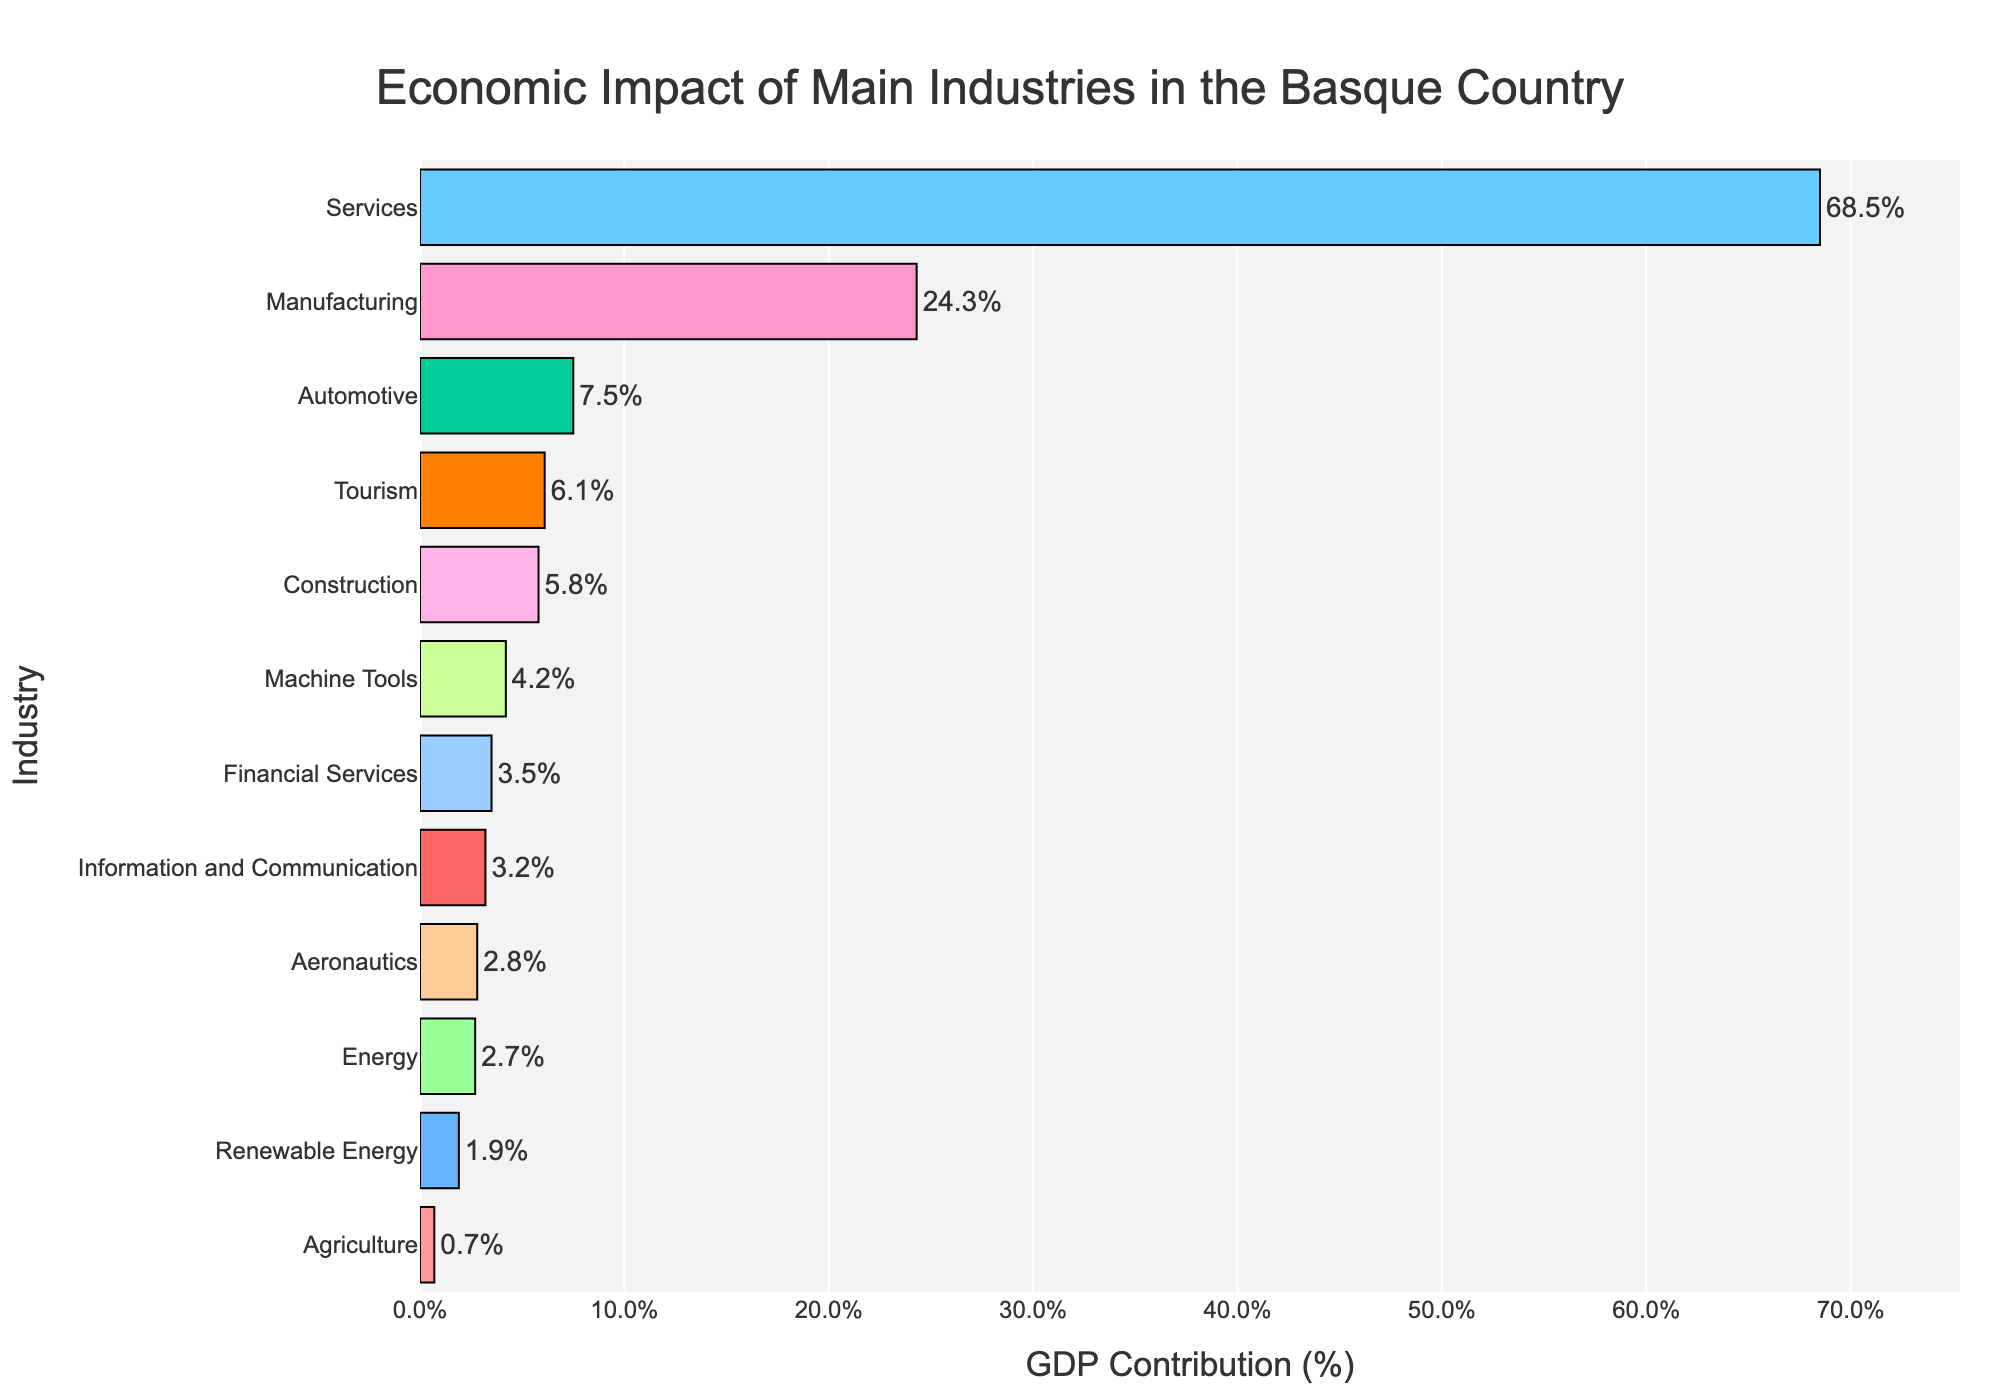Which industry has the highest GDP contribution? The bar representing the Services industry is the longest, indicating that it has the highest GDP contribution.
Answer: Services What is the total GDP contribution of Manufacturing, Automotive, and Machine Tools combined? Add the GDP contributions: Manufacturing (24.3) + Automotive (7.5) + Machine Tools (4.2). The sum is 24.3 + 7.5 + 4.2 = 36.0%.
Answer: 36.0% Which two industries contribute less than 1% to GDP? The bars for Agriculture and Renewable Energy are the shortest and positioned at around 0.7% and 1.9%, respectively. Only Agriculture is less than 1%.
Answer: Agriculture How much more does Services contribute to GDP compared to Manufacturing? Subtract the GDP contribution of Manufacturing from that of Services: 68.5 - 24.3 = 44.2%.
Answer: 44.2% What is the average GDP contribution of the bottom three industries? Sum the GDP contributions of the bottom three industries (Agriculture: 0.7%, Renewable Energy: 1.9%, and Energy: 2.7%) and divide by 3: (0.7 + 1.9 + 2.7) / 3 = 1.77%.
Answer: 1.77% Which industry has a higher GDP contribution: Financial Services or Information and Communication? Compare the bars representing Financial Services (3.5%) and Information and Communication (3.2%). Financial Services is higher.
Answer: Financial Services Is Tourism's GDP contribution higher than Construction? Compare the bars representing Tourism (6.1%) and Construction (5.8%). Tourism is slightly higher.
Answer: Yes What is the difference in GDP contribution between the Automotive and Aeronautics industries? Subtract the GDP contribution of Aeronautics from that of Automotive: 7.5 - 2.8 = 4.7%.
Answer: 4.7% Which industry has a GDP contribution closest to 3%? The bar for Information and Communication is closest to 3%, showing a GDP contribution of 3.2%.
Answer: Information and Communication What percentage of GDP do Financial Services and Construction contribute together? Add the GDP contributions: Financial Services (3.5%) + Construction (5.8%) = 9.3%.
Answer: 9.3% 